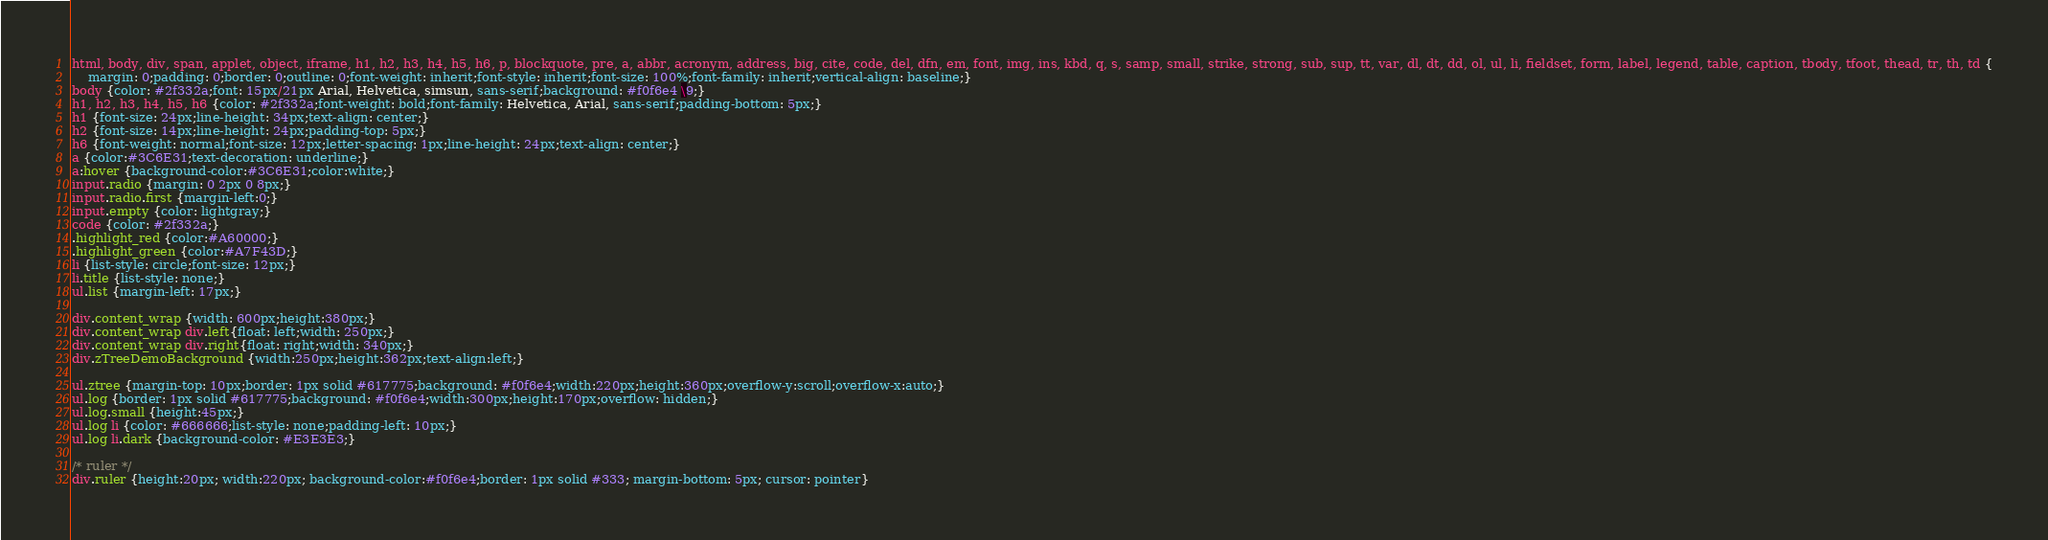<code> <loc_0><loc_0><loc_500><loc_500><_CSS_>html, body, div, span, applet, object, iframe, h1, h2, h3, h4, h5, h6, p, blockquote, pre, a, abbr, acronym, address, big, cite, code, del, dfn, em, font, img, ins, kbd, q, s, samp, small, strike, strong, sub, sup, tt, var, dl, dt, dd, ol, ul, li, fieldset, form, label, legend, table, caption, tbody, tfoot, thead, tr, th, td {
	margin: 0;padding: 0;border: 0;outline: 0;font-weight: inherit;font-style: inherit;font-size: 100%;font-family: inherit;vertical-align: baseline;}
body {color: #2f332a;font: 15px/21px Arial, Helvetica, simsun, sans-serif;background: #f0f6e4 \9;}
h1, h2, h3, h4, h5, h6 {color: #2f332a;font-weight: bold;font-family: Helvetica, Arial, sans-serif;padding-bottom: 5px;}
h1 {font-size: 24px;line-height: 34px;text-align: center;}
h2 {font-size: 14px;line-height: 24px;padding-top: 5px;}
h6 {font-weight: normal;font-size: 12px;letter-spacing: 1px;line-height: 24px;text-align: center;}
a {color:#3C6E31;text-decoration: underline;}
a:hover {background-color:#3C6E31;color:white;}
input.radio {margin: 0 2px 0 8px;}
input.radio.first {margin-left:0;}
input.empty {color: lightgray;}
code {color: #2f332a;}
.highlight_red {color:#A60000;}
.highlight_green {color:#A7F43D;}
li {list-style: circle;font-size: 12px;}
li.title {list-style: none;}
ul.list {margin-left: 17px;}

div.content_wrap {width: 600px;height:380px;}
div.content_wrap div.left{float: left;width: 250px;}
div.content_wrap div.right{float: right;width: 340px;}
div.zTreeDemoBackground {width:250px;height:362px;text-align:left;}

ul.ztree {margin-top: 10px;border: 1px solid #617775;background: #f0f6e4;width:220px;height:360px;overflow-y:scroll;overflow-x:auto;}
ul.log {border: 1px solid #617775;background: #f0f6e4;width:300px;height:170px;overflow: hidden;}
ul.log.small {height:45px;}
ul.log li {color: #666666;list-style: none;padding-left: 10px;}
ul.log li.dark {background-color: #E3E3E3;}

/* ruler */
div.ruler {height:20px; width:220px; background-color:#f0f6e4;border: 1px solid #333; margin-bottom: 5px; cursor: pointer}</code> 